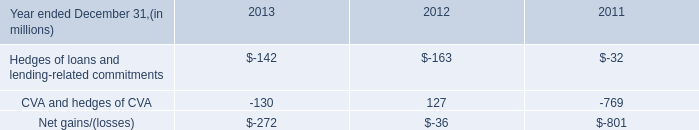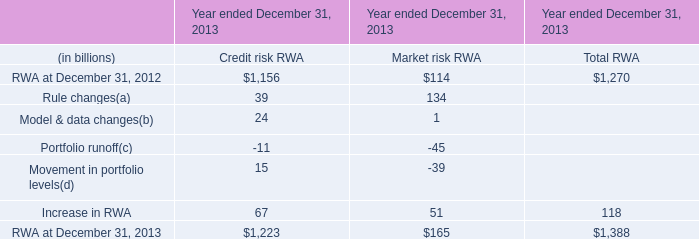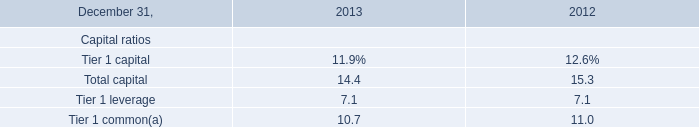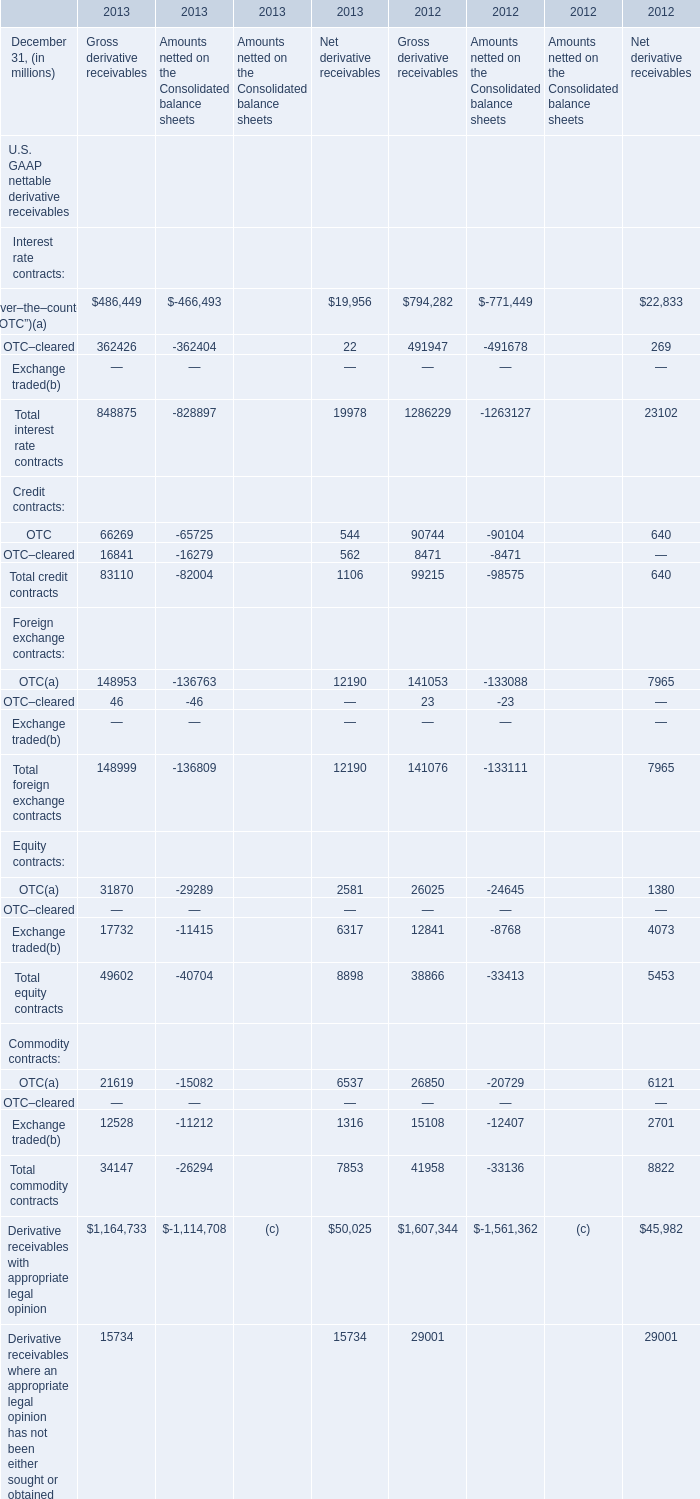what was the ratio of the firm 2019s cra loan portfolio in 2013 compared to 2012 
Computations: (18 / 16)
Answer: 1.125. 